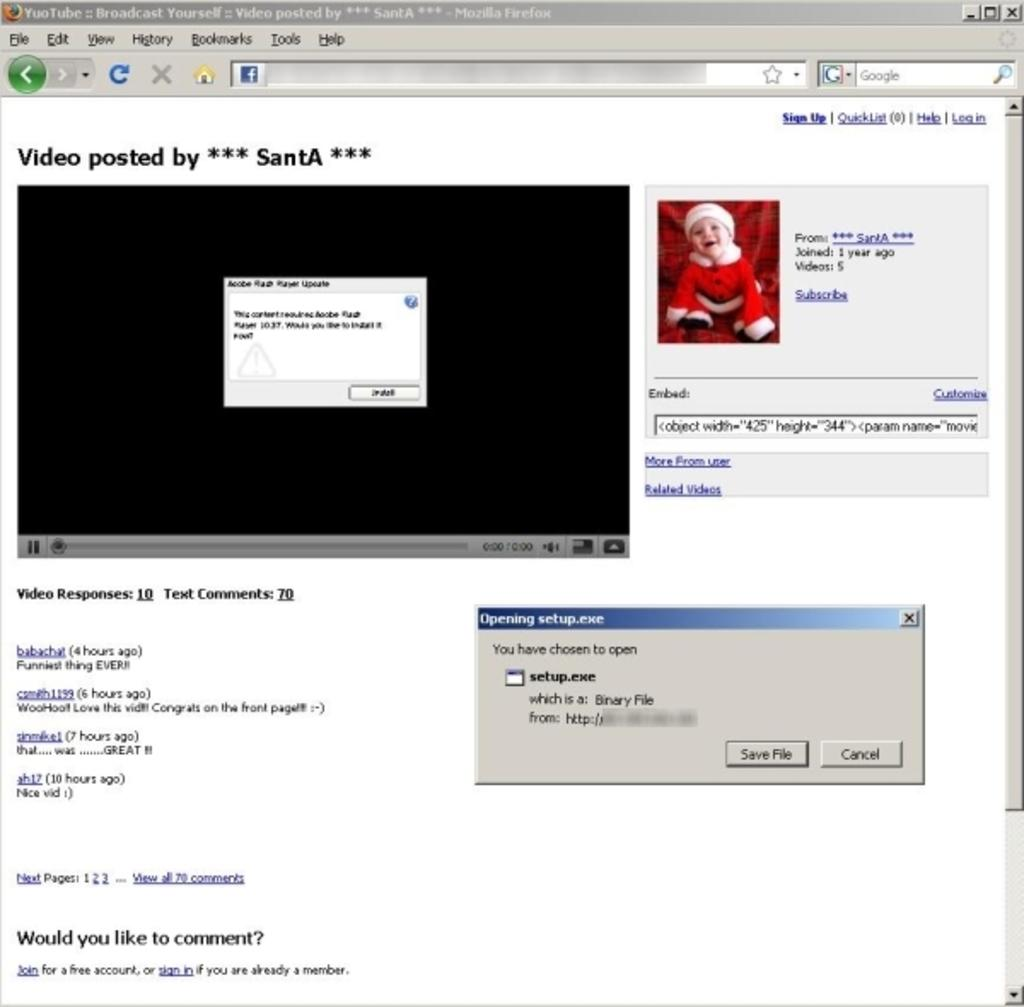<image>
Relay a brief, clear account of the picture shown. John posts a Christmas video of his son Tyler on Youtube. 